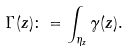<formula> <loc_0><loc_0><loc_500><loc_500>\Gamma ( z ) \colon = \int _ { \eta _ { z } } \gamma ( z ) .</formula> 